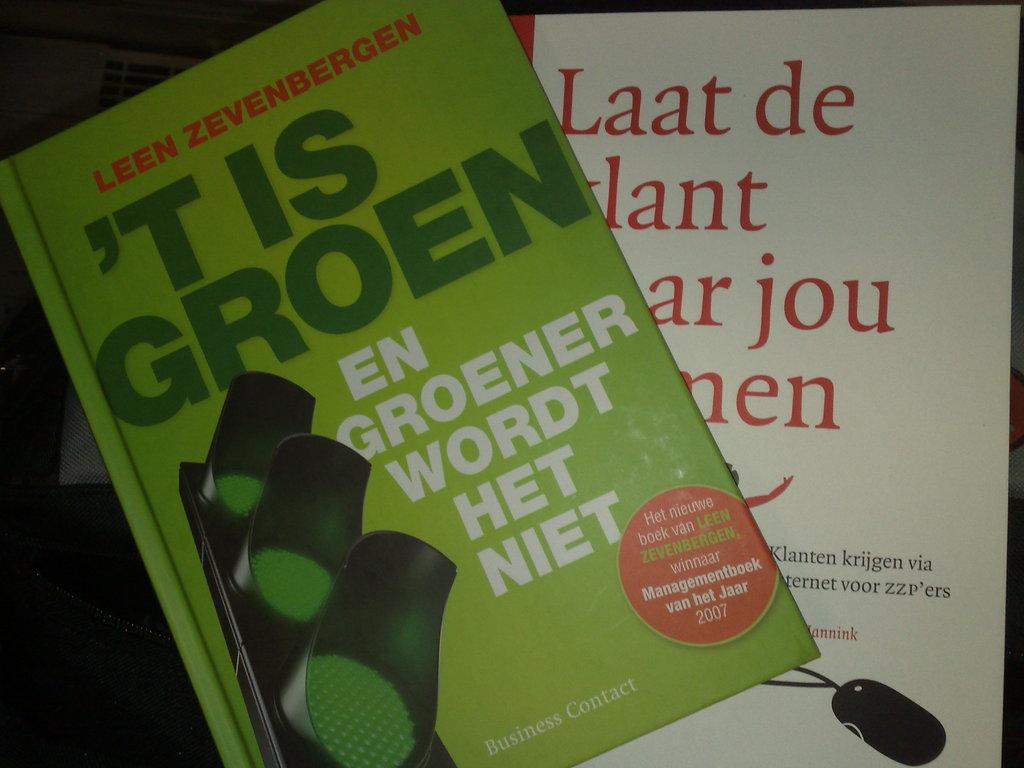Who is the publisher of the green covered book?
Your answer should be compact. Business contact. What is the first word on the white book?
Offer a very short reply. Laat. 